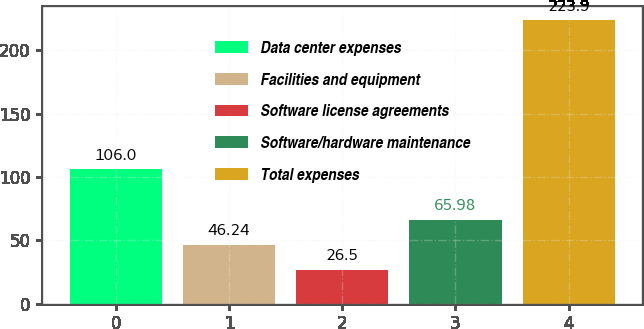Convert chart to OTSL. <chart><loc_0><loc_0><loc_500><loc_500><bar_chart><fcel>Data center expenses<fcel>Facilities and equipment<fcel>Software license agreements<fcel>Software/hardware maintenance<fcel>Total expenses<nl><fcel>106<fcel>46.24<fcel>26.5<fcel>65.98<fcel>223.9<nl></chart> 